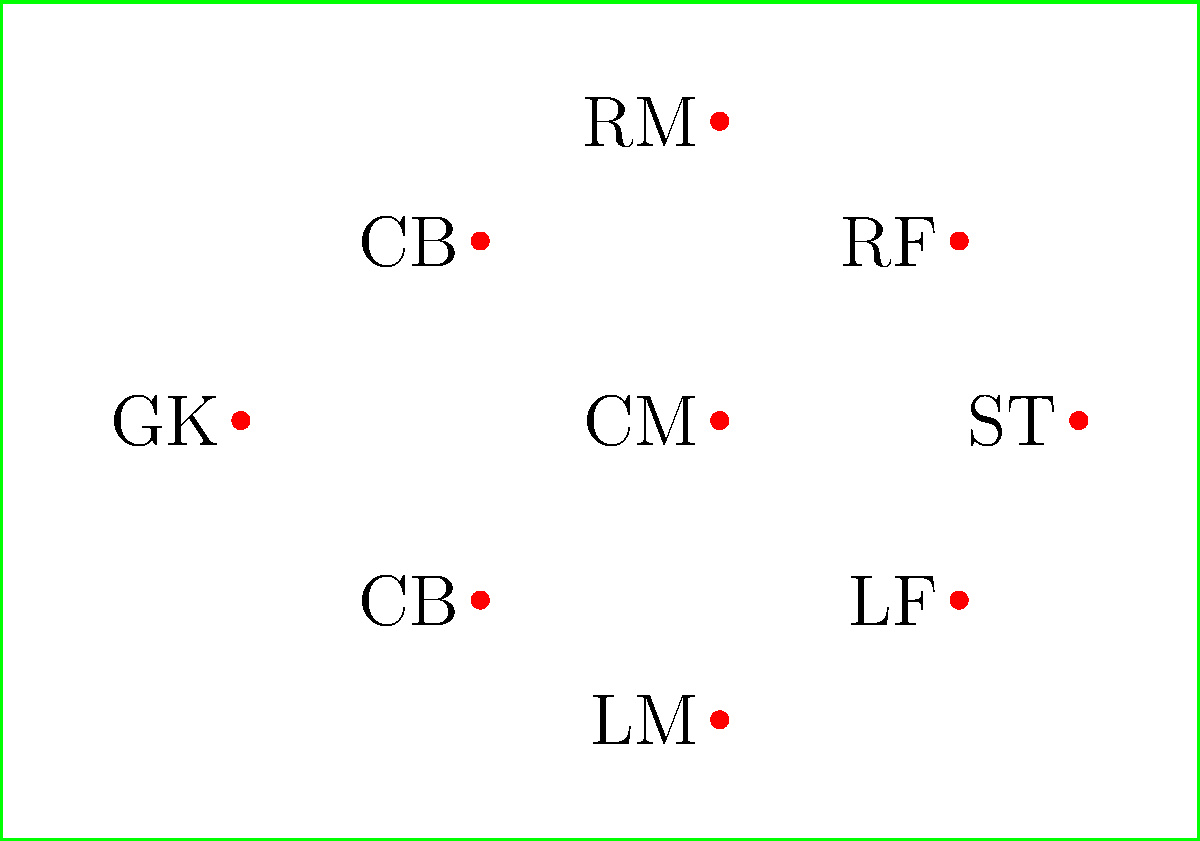As a seasoned football historian, you're analyzing classic formations. Identify the formation depicted in this aerial view diagram, which was popular in the late 1980s and early 1990s, especially in England. To identify this formation, let's break it down step-by-step:

1. Count the number of players: There are 9 outfield players (excluding the goalkeeper).

2. Analyze the defensive line:
   - We see 2 players positioned as center-backs (CB).

3. Examine the midfield:
   - There are 3 midfielders spread across the width of the field.
   - One central midfielder (CM) and two wide midfielders (LM and RM).

4. Look at the forward line:
   - We have 3 forward players.
   - Two are slightly withdrawn (LF and RF), while one is more advanced (ST).

5. Considering the arrangement:
   - The formation has 2 defenders, 3 midfielders, and 3 forwards.
   - The two withdrawn forwards act as a link between midfield and attack.

6. Recall historical context:
   - This formation was indeed popular in England during the late 1980s and early 1990s.
   - It was famously used by teams like Liverpool and Nottingham Forest.

Given this analysis, the formation depicted is the 2-3-3-2 or more commonly known as the 3-5-2, where the two withdrawn forwards are considered part of the midfield five in modern terminology.
Answer: 3-5-2 